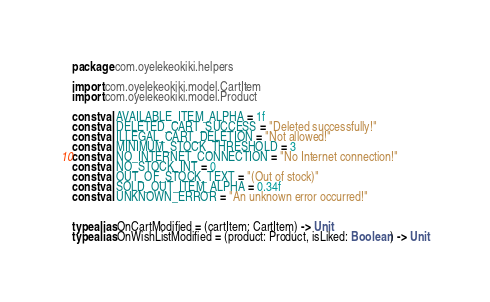Convert code to text. <code><loc_0><loc_0><loc_500><loc_500><_Kotlin_>package com.oyelekeokiki.helpers

import com.oyelekeokiki.model.CartItem
import com.oyelekeokiki.model.Product

const val AVAILABLE_ITEM_ALPHA = 1f
const val DELETED_CART_SUCCESS = "Deleted successfully!"
const val ILLEGAL_CART_DELETION = "Not allowed!"
const val MINIMUM_STOCK_THRESHOLD = 3
const val NO_INTERNET_CONNECTION = "No Internet connection!"
const val NO_STOCK_INT = 0
const val OUT_OF_STOCK_TEXT = "(Out of stock)"
const val SOLD_OUT_ITEM_ALPHA = 0.34f
const val UNKNOWN_ERROR = "An unknown error occurred!"


typealias OnCartModified = (cartItem: CartItem) -> Unit
typealias OnWishListModified = (product: Product, isLiked: Boolean) -> Unit
</code> 